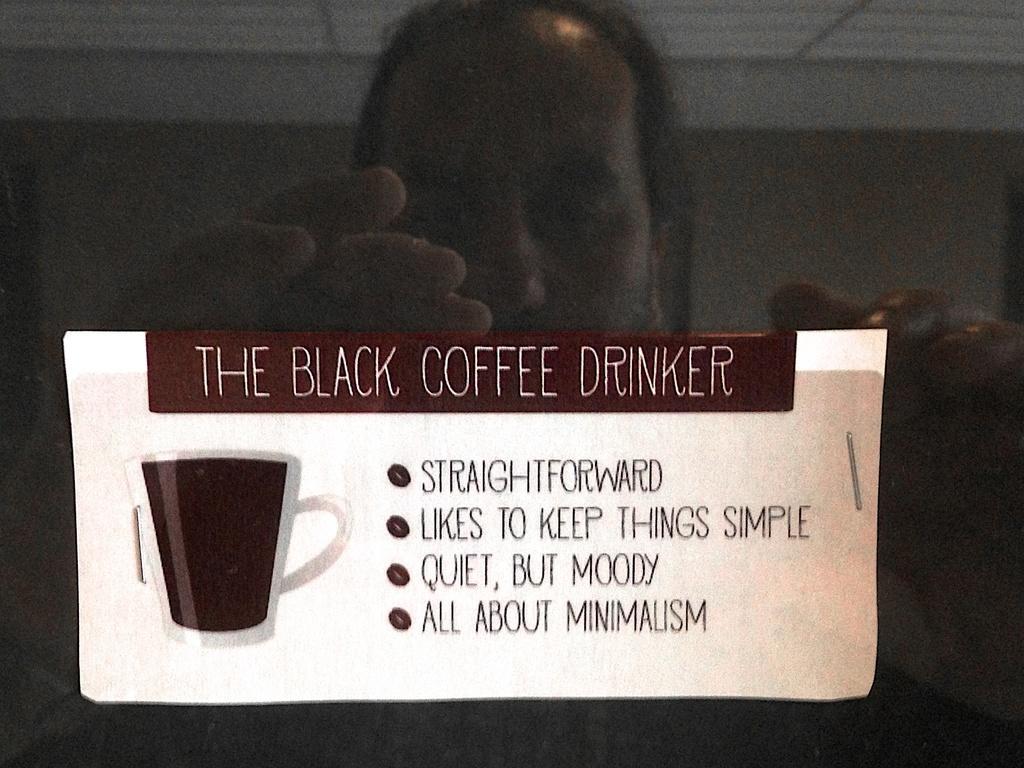How would you summarize this image in a sentence or two? In this picture I can see a man standing and I can see a paper with some text. 